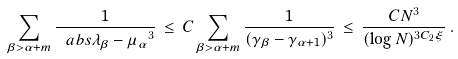<formula> <loc_0><loc_0><loc_500><loc_500>\sum _ { \beta > \alpha + m } \frac { 1 } { \ a b s { \lambda _ { \beta } - \mu _ { \alpha } } ^ { 3 } } \, \leq \, C \sum _ { \beta > \alpha + m } \frac { 1 } { ( \gamma _ { \beta } - \gamma _ { \alpha + 1 } ) ^ { 3 } } \, \leq \, \frac { C N ^ { 3 } } { ( \log N ) ^ { 3 C _ { 2 } \xi } } \, .</formula> 